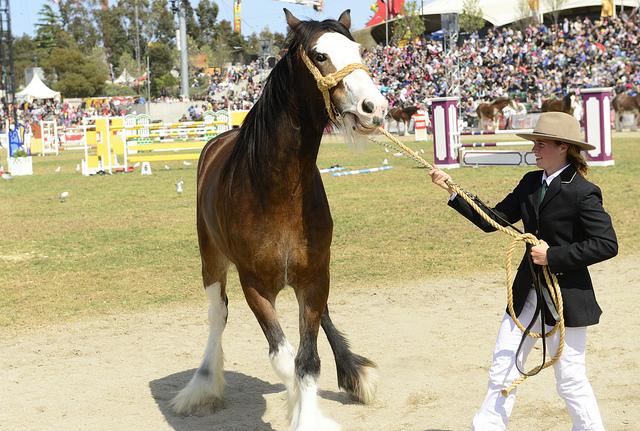How long before that horse gets angry and eats that woman's hat?
Answer briefly. Never. Should this horse have its hair in braids?
Answer briefly. No. Is this a rodeo?
Quick response, please. No. 